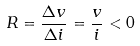Convert formula to latex. <formula><loc_0><loc_0><loc_500><loc_500>R = \frac { \Delta v } { \Delta i } = \frac { v } { i } < 0</formula> 